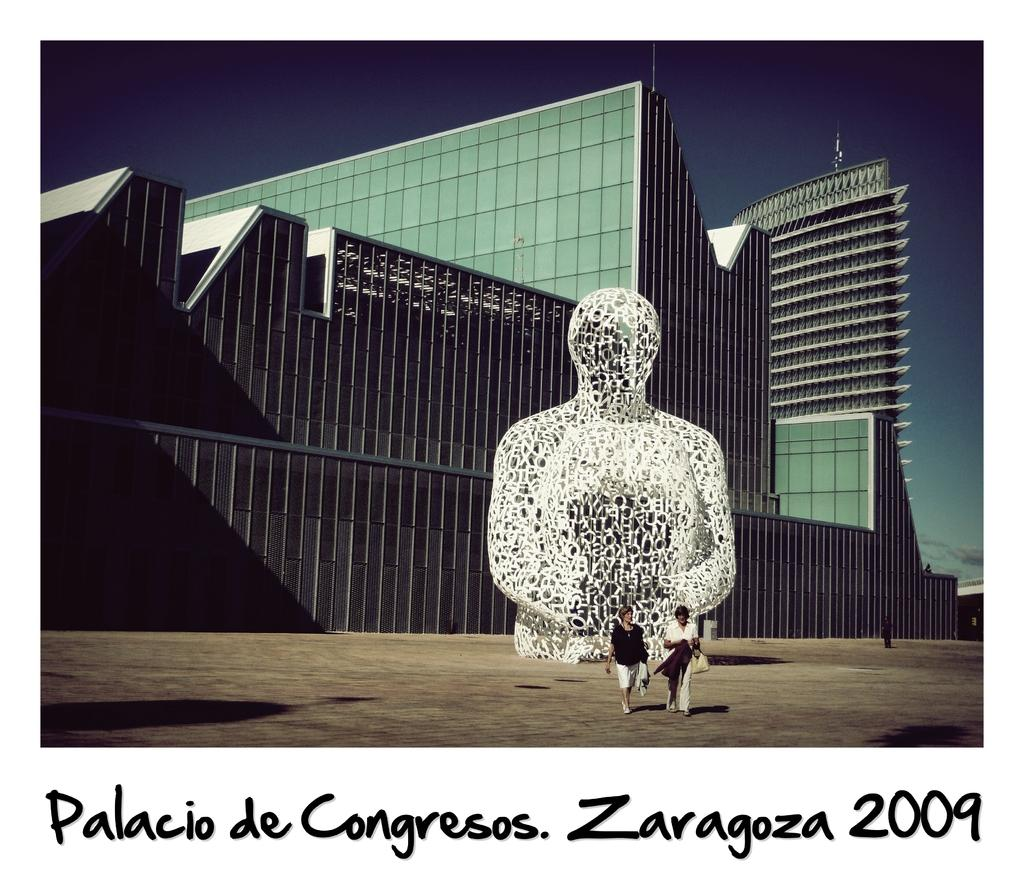<image>
Summarize the visual content of the image. A statue and two people walking in the Palacio de Congresos in Zaragoza in 2009. 